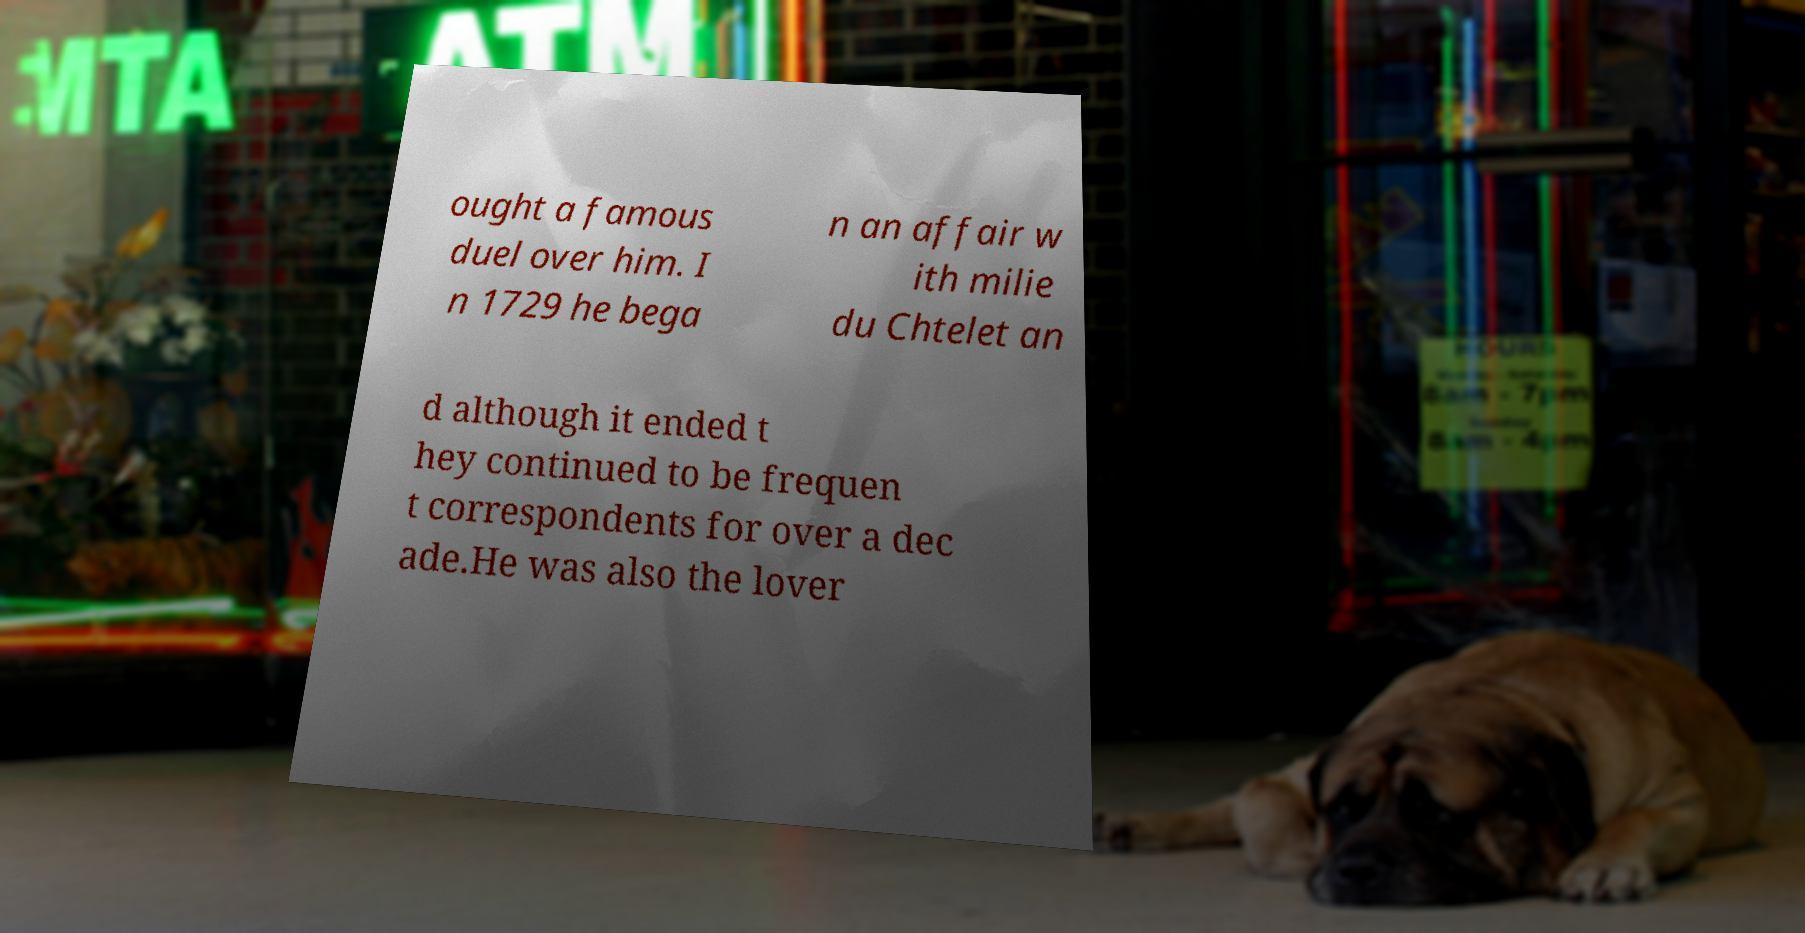Can you accurately transcribe the text from the provided image for me? ought a famous duel over him. I n 1729 he bega n an affair w ith milie du Chtelet an d although it ended t hey continued to be frequen t correspondents for over a dec ade.He was also the lover 